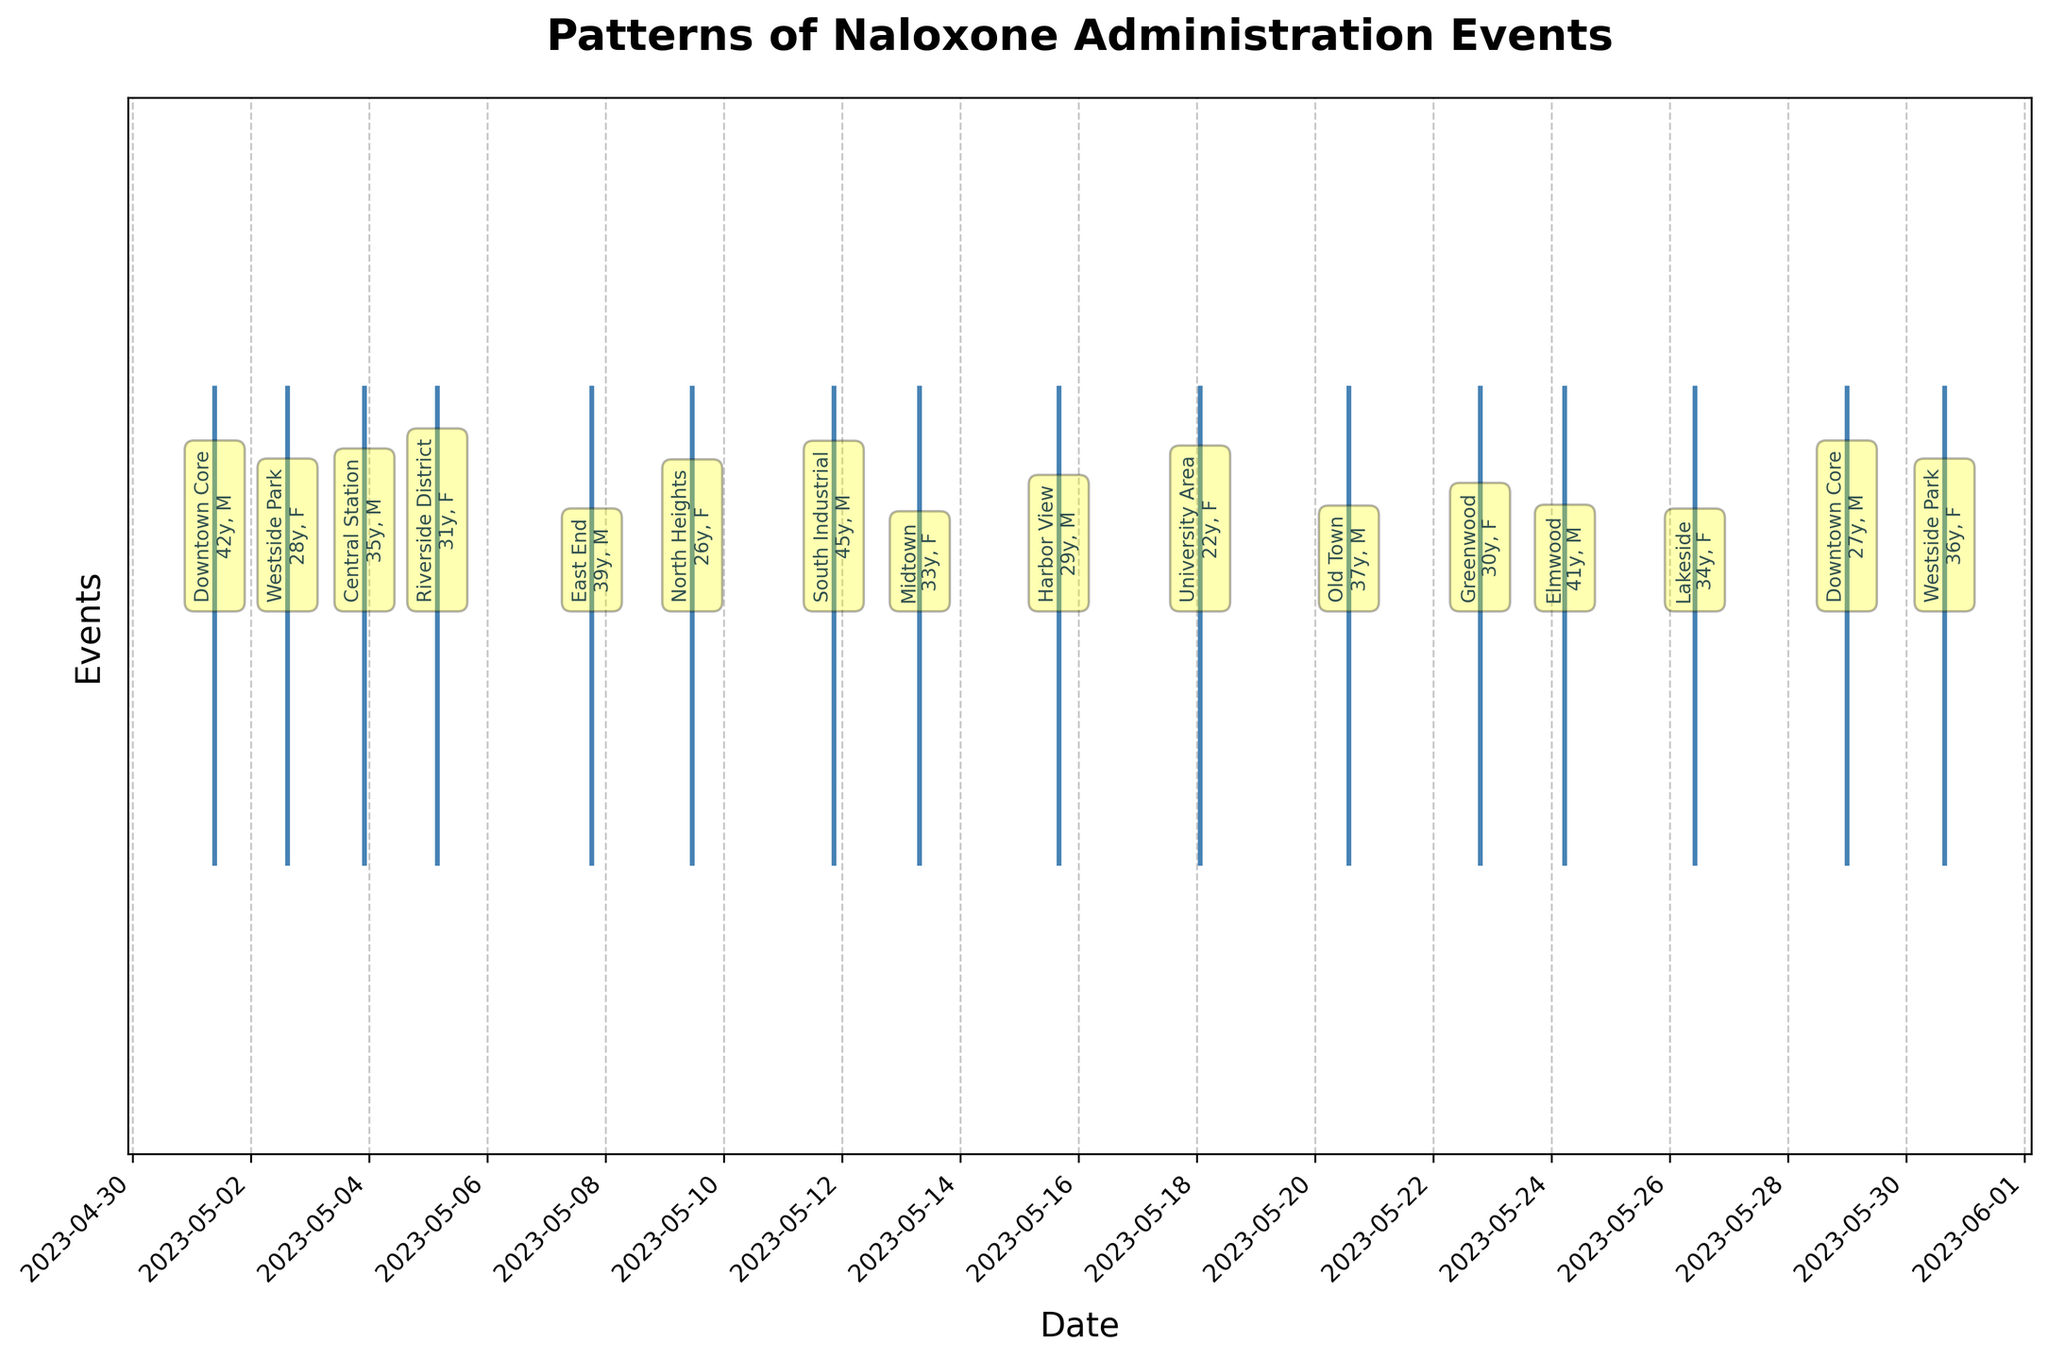How many naloxone administration events are shown in the figure? The figure displays an event plot with each event represented by a line. To determine the count, tally the number of lines in the plot.
Answer: 15 What is the date range covered by the naloxone administration events? The x-axis of the event plot indicates the range of dates. By looking at the first and last dates marked, you can identify the range.
Answer: 2023-05-01 to 2023-05-30 Which location appears first chronologically? By examining the x-axis and looking at the annotations for each event, the earliest event annotation indicates the location.
Answer: Downtown Core What times of day are naloxone administrations most common based on the plot? Observing the figure annotations, list the times associated with the events. Identify commonalities or frequent times.
Answer: No specific time stands out; events vary throughout the day How many events occurred in the Westside Park location? By identifying annotations specifically mentioning "Westside Park", you count the occurrences.
Answer: 2 Which patient age appears most frequently? Examine the annotations for each event to find common ages and identify the most frequent one.
Answer: Ages are quite varied; no clear frequent age What is the sum of the ages of all male patients? Identify patient ages from the annotations associated with male patients (gender as 'M'), then sum the ages together.
Answer: 42 + 35 + 39 + 45 + 29 + 41 + 27 = 258 Are there more naloxone administrations in the first half or the second half of the month? Count the number of events annotated in the first half (1-15) and compare to those in the second half (16-30).
Answer: First half: 8, Second half: 7 What is the average age of female patients based on the annotations? Extract ages for female patients ('F') and compute their mean by summing them up and dividing by the number of female patients.
Answer: (28 + 31 + 26 + 33 + 22 + 30 + 36) / 7 = 29.43 Which day has the highest frequency of naloxone administrations? Examine the annotations’ dates to identify any dates with multiple occurrences.
Answer: No specific day has more than one event 